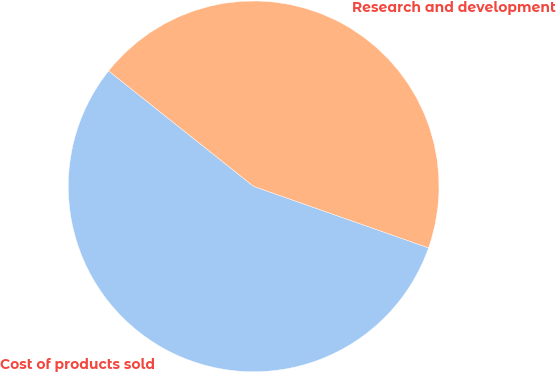<chart> <loc_0><loc_0><loc_500><loc_500><pie_chart><fcel>Cost of products sold<fcel>Research and development<nl><fcel>55.32%<fcel>44.68%<nl></chart> 